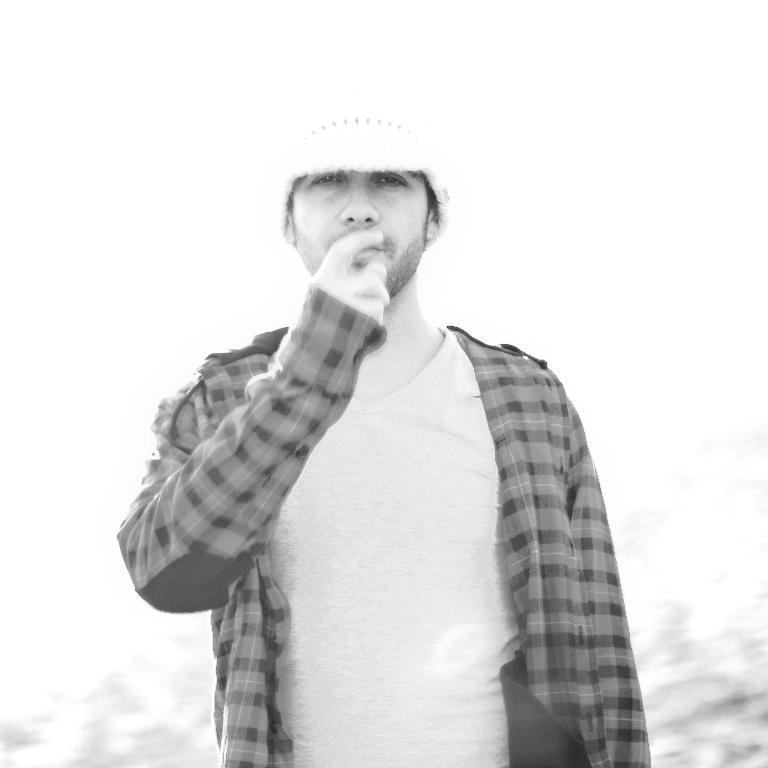What is the main subject in the foreground of the image? There is a man standing in the foreground of the image. What is the man wearing in the image? The man is wearing a shirt in the image. What is the color scheme of the image? The image is in black and white. What is the background of the image? There is a white background in the image. What is the name of the man's uncle in the image? There is no information about the man's uncle in the image, as it only shows a man standing in the foreground. What is the birth date of the man in the image? There is no information about the man's birth date in the image, as it only shows a man standing in the foreground. 